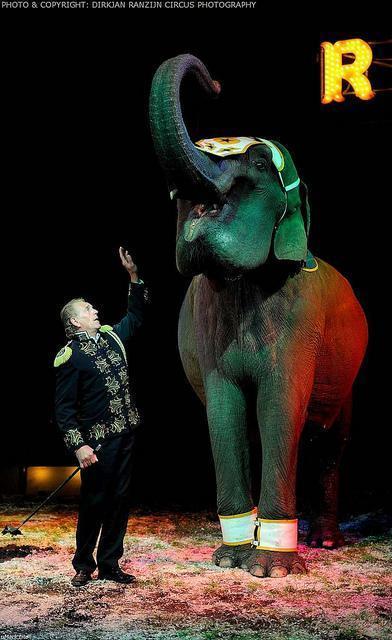How many legs can you see in this picture?
Give a very brief answer. 5. How many elephants are there?
Give a very brief answer. 1. How many skateboard wheels are there?
Give a very brief answer. 0. 